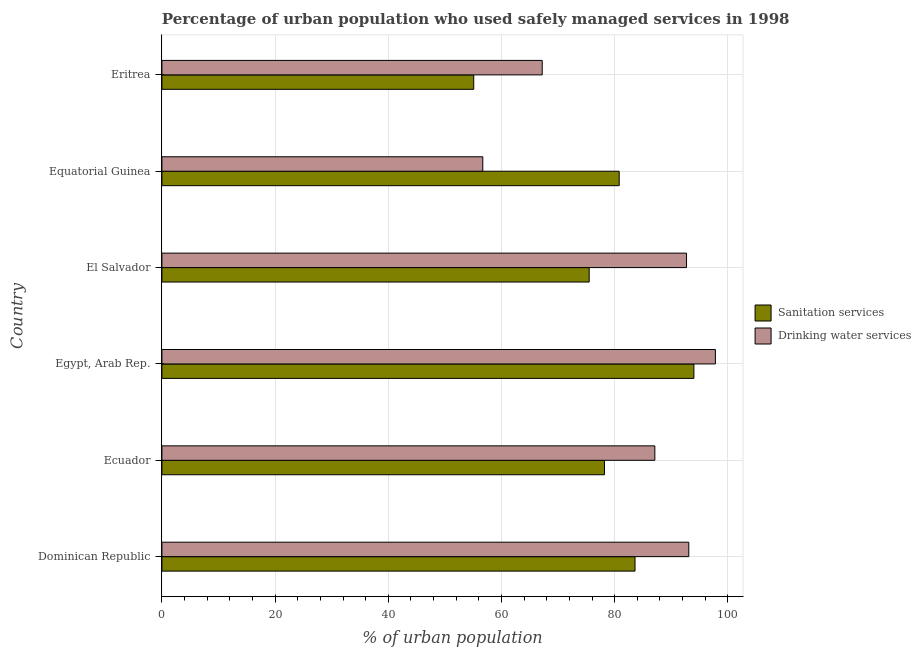How many groups of bars are there?
Your answer should be compact. 6. Are the number of bars per tick equal to the number of legend labels?
Your answer should be very brief. Yes. Are the number of bars on each tick of the Y-axis equal?
Provide a short and direct response. Yes. How many bars are there on the 5th tick from the bottom?
Offer a terse response. 2. What is the label of the 4th group of bars from the top?
Provide a succinct answer. Egypt, Arab Rep. In how many cases, is the number of bars for a given country not equal to the number of legend labels?
Provide a short and direct response. 0. What is the percentage of urban population who used sanitation services in Equatorial Guinea?
Ensure brevity in your answer.  80.8. Across all countries, what is the maximum percentage of urban population who used drinking water services?
Ensure brevity in your answer.  97.8. Across all countries, what is the minimum percentage of urban population who used sanitation services?
Ensure brevity in your answer.  55.1. In which country was the percentage of urban population who used drinking water services maximum?
Keep it short and to the point. Egypt, Arab Rep. In which country was the percentage of urban population who used drinking water services minimum?
Your answer should be very brief. Equatorial Guinea. What is the total percentage of urban population who used drinking water services in the graph?
Your answer should be compact. 494.6. What is the difference between the percentage of urban population who used drinking water services in El Salvador and that in Equatorial Guinea?
Provide a short and direct response. 36. What is the difference between the percentage of urban population who used drinking water services in Equatorial Guinea and the percentage of urban population who used sanitation services in El Salvador?
Provide a short and direct response. -18.8. What is the average percentage of urban population who used drinking water services per country?
Ensure brevity in your answer.  82.43. What is the difference between the percentage of urban population who used drinking water services and percentage of urban population who used sanitation services in Dominican Republic?
Your answer should be compact. 9.5. In how many countries, is the percentage of urban population who used sanitation services greater than 8 %?
Offer a terse response. 6. What is the ratio of the percentage of urban population who used sanitation services in Dominican Republic to that in Ecuador?
Offer a very short reply. 1.07. Is the difference between the percentage of urban population who used drinking water services in Dominican Republic and Egypt, Arab Rep. greater than the difference between the percentage of urban population who used sanitation services in Dominican Republic and Egypt, Arab Rep.?
Provide a short and direct response. Yes. What is the difference between the highest and the lowest percentage of urban population who used drinking water services?
Your answer should be compact. 41.1. In how many countries, is the percentage of urban population who used drinking water services greater than the average percentage of urban population who used drinking water services taken over all countries?
Make the answer very short. 4. What does the 1st bar from the top in Equatorial Guinea represents?
Your response must be concise. Drinking water services. What does the 1st bar from the bottom in Ecuador represents?
Offer a very short reply. Sanitation services. Are all the bars in the graph horizontal?
Provide a short and direct response. Yes. How many legend labels are there?
Provide a succinct answer. 2. What is the title of the graph?
Provide a short and direct response. Percentage of urban population who used safely managed services in 1998. What is the label or title of the X-axis?
Offer a terse response. % of urban population. What is the label or title of the Y-axis?
Give a very brief answer. Country. What is the % of urban population in Sanitation services in Dominican Republic?
Give a very brief answer. 83.6. What is the % of urban population in Drinking water services in Dominican Republic?
Give a very brief answer. 93.1. What is the % of urban population in Sanitation services in Ecuador?
Offer a very short reply. 78.2. What is the % of urban population of Drinking water services in Ecuador?
Your answer should be compact. 87.1. What is the % of urban population in Sanitation services in Egypt, Arab Rep.?
Offer a very short reply. 94. What is the % of urban population of Drinking water services in Egypt, Arab Rep.?
Your response must be concise. 97.8. What is the % of urban population in Sanitation services in El Salvador?
Offer a terse response. 75.5. What is the % of urban population of Drinking water services in El Salvador?
Provide a short and direct response. 92.7. What is the % of urban population in Sanitation services in Equatorial Guinea?
Ensure brevity in your answer.  80.8. What is the % of urban population in Drinking water services in Equatorial Guinea?
Make the answer very short. 56.7. What is the % of urban population of Sanitation services in Eritrea?
Provide a succinct answer. 55.1. What is the % of urban population in Drinking water services in Eritrea?
Offer a very short reply. 67.2. Across all countries, what is the maximum % of urban population in Sanitation services?
Provide a short and direct response. 94. Across all countries, what is the maximum % of urban population in Drinking water services?
Offer a terse response. 97.8. Across all countries, what is the minimum % of urban population in Sanitation services?
Keep it short and to the point. 55.1. Across all countries, what is the minimum % of urban population of Drinking water services?
Your answer should be compact. 56.7. What is the total % of urban population of Sanitation services in the graph?
Provide a succinct answer. 467.2. What is the total % of urban population of Drinking water services in the graph?
Your answer should be very brief. 494.6. What is the difference between the % of urban population of Sanitation services in Dominican Republic and that in Egypt, Arab Rep.?
Offer a very short reply. -10.4. What is the difference between the % of urban population in Drinking water services in Dominican Republic and that in Egypt, Arab Rep.?
Provide a succinct answer. -4.7. What is the difference between the % of urban population in Sanitation services in Dominican Republic and that in El Salvador?
Provide a succinct answer. 8.1. What is the difference between the % of urban population of Drinking water services in Dominican Republic and that in El Salvador?
Your answer should be very brief. 0.4. What is the difference between the % of urban population of Drinking water services in Dominican Republic and that in Equatorial Guinea?
Ensure brevity in your answer.  36.4. What is the difference between the % of urban population of Drinking water services in Dominican Republic and that in Eritrea?
Ensure brevity in your answer.  25.9. What is the difference between the % of urban population of Sanitation services in Ecuador and that in Egypt, Arab Rep.?
Provide a short and direct response. -15.8. What is the difference between the % of urban population of Drinking water services in Ecuador and that in Egypt, Arab Rep.?
Your answer should be compact. -10.7. What is the difference between the % of urban population in Drinking water services in Ecuador and that in El Salvador?
Give a very brief answer. -5.6. What is the difference between the % of urban population of Sanitation services in Ecuador and that in Equatorial Guinea?
Provide a succinct answer. -2.6. What is the difference between the % of urban population of Drinking water services in Ecuador and that in Equatorial Guinea?
Your answer should be very brief. 30.4. What is the difference between the % of urban population of Sanitation services in Ecuador and that in Eritrea?
Keep it short and to the point. 23.1. What is the difference between the % of urban population of Sanitation services in Egypt, Arab Rep. and that in El Salvador?
Your answer should be very brief. 18.5. What is the difference between the % of urban population in Drinking water services in Egypt, Arab Rep. and that in El Salvador?
Keep it short and to the point. 5.1. What is the difference between the % of urban population of Drinking water services in Egypt, Arab Rep. and that in Equatorial Guinea?
Provide a short and direct response. 41.1. What is the difference between the % of urban population of Sanitation services in Egypt, Arab Rep. and that in Eritrea?
Keep it short and to the point. 38.9. What is the difference between the % of urban population in Drinking water services in Egypt, Arab Rep. and that in Eritrea?
Offer a terse response. 30.6. What is the difference between the % of urban population of Drinking water services in El Salvador and that in Equatorial Guinea?
Offer a terse response. 36. What is the difference between the % of urban population of Sanitation services in El Salvador and that in Eritrea?
Offer a very short reply. 20.4. What is the difference between the % of urban population of Drinking water services in El Salvador and that in Eritrea?
Provide a succinct answer. 25.5. What is the difference between the % of urban population in Sanitation services in Equatorial Guinea and that in Eritrea?
Make the answer very short. 25.7. What is the difference between the % of urban population in Sanitation services in Dominican Republic and the % of urban population in Drinking water services in Ecuador?
Your response must be concise. -3.5. What is the difference between the % of urban population of Sanitation services in Dominican Republic and the % of urban population of Drinking water services in Equatorial Guinea?
Give a very brief answer. 26.9. What is the difference between the % of urban population in Sanitation services in Dominican Republic and the % of urban population in Drinking water services in Eritrea?
Offer a very short reply. 16.4. What is the difference between the % of urban population of Sanitation services in Ecuador and the % of urban population of Drinking water services in Egypt, Arab Rep.?
Your response must be concise. -19.6. What is the difference between the % of urban population of Sanitation services in Ecuador and the % of urban population of Drinking water services in Eritrea?
Give a very brief answer. 11. What is the difference between the % of urban population of Sanitation services in Egypt, Arab Rep. and the % of urban population of Drinking water services in Equatorial Guinea?
Give a very brief answer. 37.3. What is the difference between the % of urban population of Sanitation services in Egypt, Arab Rep. and the % of urban population of Drinking water services in Eritrea?
Your answer should be compact. 26.8. What is the average % of urban population of Sanitation services per country?
Keep it short and to the point. 77.87. What is the average % of urban population in Drinking water services per country?
Give a very brief answer. 82.43. What is the difference between the % of urban population of Sanitation services and % of urban population of Drinking water services in Dominican Republic?
Ensure brevity in your answer.  -9.5. What is the difference between the % of urban population of Sanitation services and % of urban population of Drinking water services in El Salvador?
Make the answer very short. -17.2. What is the difference between the % of urban population in Sanitation services and % of urban population in Drinking water services in Equatorial Guinea?
Provide a succinct answer. 24.1. What is the difference between the % of urban population in Sanitation services and % of urban population in Drinking water services in Eritrea?
Keep it short and to the point. -12.1. What is the ratio of the % of urban population in Sanitation services in Dominican Republic to that in Ecuador?
Make the answer very short. 1.07. What is the ratio of the % of urban population in Drinking water services in Dominican Republic to that in Ecuador?
Offer a very short reply. 1.07. What is the ratio of the % of urban population in Sanitation services in Dominican Republic to that in Egypt, Arab Rep.?
Offer a very short reply. 0.89. What is the ratio of the % of urban population in Drinking water services in Dominican Republic to that in Egypt, Arab Rep.?
Ensure brevity in your answer.  0.95. What is the ratio of the % of urban population of Sanitation services in Dominican Republic to that in El Salvador?
Give a very brief answer. 1.11. What is the ratio of the % of urban population of Sanitation services in Dominican Republic to that in Equatorial Guinea?
Provide a succinct answer. 1.03. What is the ratio of the % of urban population of Drinking water services in Dominican Republic to that in Equatorial Guinea?
Provide a short and direct response. 1.64. What is the ratio of the % of urban population of Sanitation services in Dominican Republic to that in Eritrea?
Ensure brevity in your answer.  1.52. What is the ratio of the % of urban population in Drinking water services in Dominican Republic to that in Eritrea?
Give a very brief answer. 1.39. What is the ratio of the % of urban population of Sanitation services in Ecuador to that in Egypt, Arab Rep.?
Provide a short and direct response. 0.83. What is the ratio of the % of urban population of Drinking water services in Ecuador to that in Egypt, Arab Rep.?
Make the answer very short. 0.89. What is the ratio of the % of urban population of Sanitation services in Ecuador to that in El Salvador?
Your response must be concise. 1.04. What is the ratio of the % of urban population in Drinking water services in Ecuador to that in El Salvador?
Give a very brief answer. 0.94. What is the ratio of the % of urban population of Sanitation services in Ecuador to that in Equatorial Guinea?
Offer a terse response. 0.97. What is the ratio of the % of urban population of Drinking water services in Ecuador to that in Equatorial Guinea?
Your response must be concise. 1.54. What is the ratio of the % of urban population of Sanitation services in Ecuador to that in Eritrea?
Provide a succinct answer. 1.42. What is the ratio of the % of urban population in Drinking water services in Ecuador to that in Eritrea?
Provide a short and direct response. 1.3. What is the ratio of the % of urban population in Sanitation services in Egypt, Arab Rep. to that in El Salvador?
Keep it short and to the point. 1.25. What is the ratio of the % of urban population in Drinking water services in Egypt, Arab Rep. to that in El Salvador?
Your response must be concise. 1.05. What is the ratio of the % of urban population in Sanitation services in Egypt, Arab Rep. to that in Equatorial Guinea?
Provide a succinct answer. 1.16. What is the ratio of the % of urban population in Drinking water services in Egypt, Arab Rep. to that in Equatorial Guinea?
Provide a short and direct response. 1.72. What is the ratio of the % of urban population of Sanitation services in Egypt, Arab Rep. to that in Eritrea?
Offer a terse response. 1.71. What is the ratio of the % of urban population of Drinking water services in Egypt, Arab Rep. to that in Eritrea?
Offer a very short reply. 1.46. What is the ratio of the % of urban population in Sanitation services in El Salvador to that in Equatorial Guinea?
Your answer should be very brief. 0.93. What is the ratio of the % of urban population of Drinking water services in El Salvador to that in Equatorial Guinea?
Provide a succinct answer. 1.63. What is the ratio of the % of urban population in Sanitation services in El Salvador to that in Eritrea?
Provide a succinct answer. 1.37. What is the ratio of the % of urban population of Drinking water services in El Salvador to that in Eritrea?
Make the answer very short. 1.38. What is the ratio of the % of urban population in Sanitation services in Equatorial Guinea to that in Eritrea?
Ensure brevity in your answer.  1.47. What is the ratio of the % of urban population in Drinking water services in Equatorial Guinea to that in Eritrea?
Offer a very short reply. 0.84. What is the difference between the highest and the second highest % of urban population of Sanitation services?
Your answer should be compact. 10.4. What is the difference between the highest and the second highest % of urban population of Drinking water services?
Your response must be concise. 4.7. What is the difference between the highest and the lowest % of urban population of Sanitation services?
Give a very brief answer. 38.9. What is the difference between the highest and the lowest % of urban population of Drinking water services?
Ensure brevity in your answer.  41.1. 